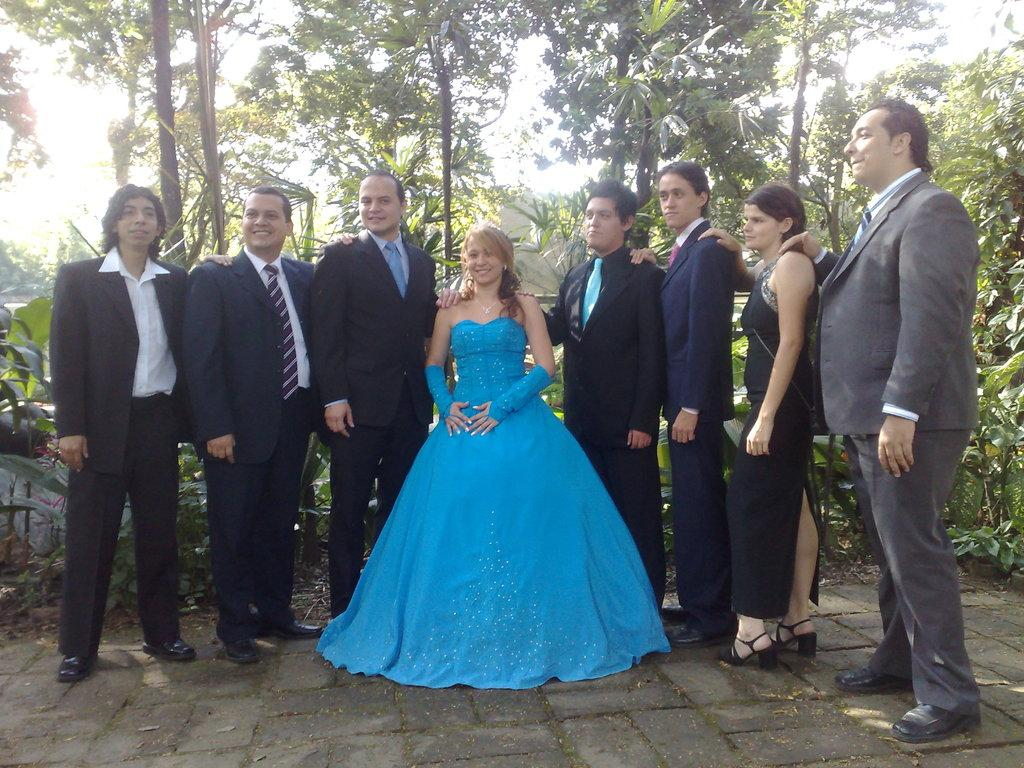How many people are in the image? There is a group of people in the image. Where are the people located in the image? The people are standing on a walkway. What can be seen in the background of the image? There are trees and plants in the background of the image. What type of lamp is hanging from the tree in the image? There is no lamp present in the image; it only features a group of people, a walkway, and trees and plants in the background. 